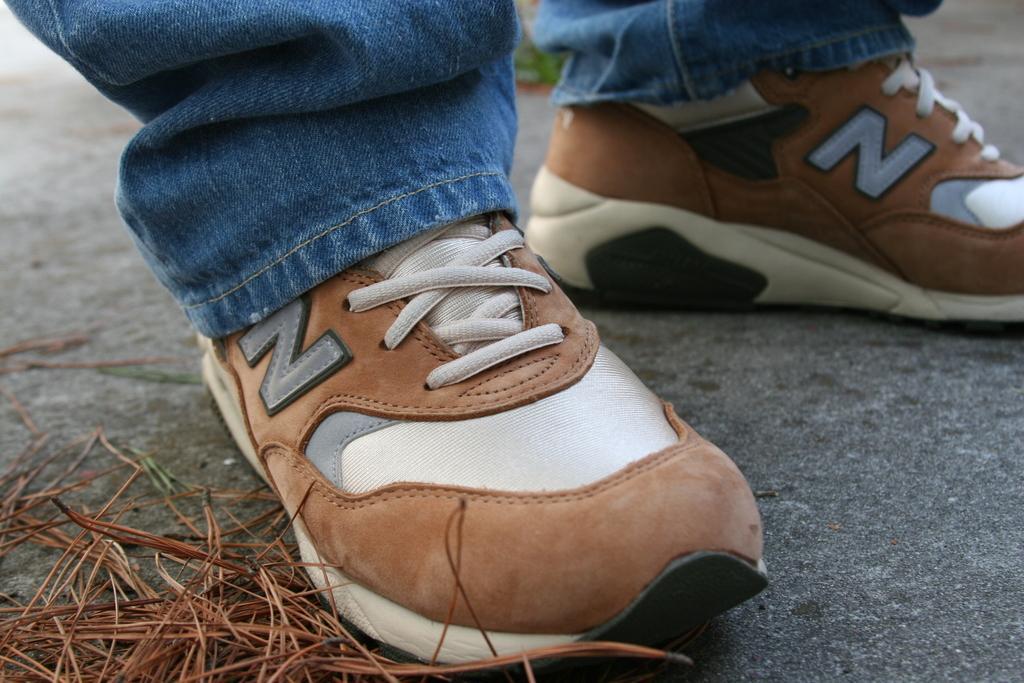Could you give a brief overview of what you see in this image? In this picture, we see the legs of a person who is wearing the blue jeans is wearing the shoes. These shoes are in brown and white color. At the bottom of the picture, we see the road and we see something in brown color. 